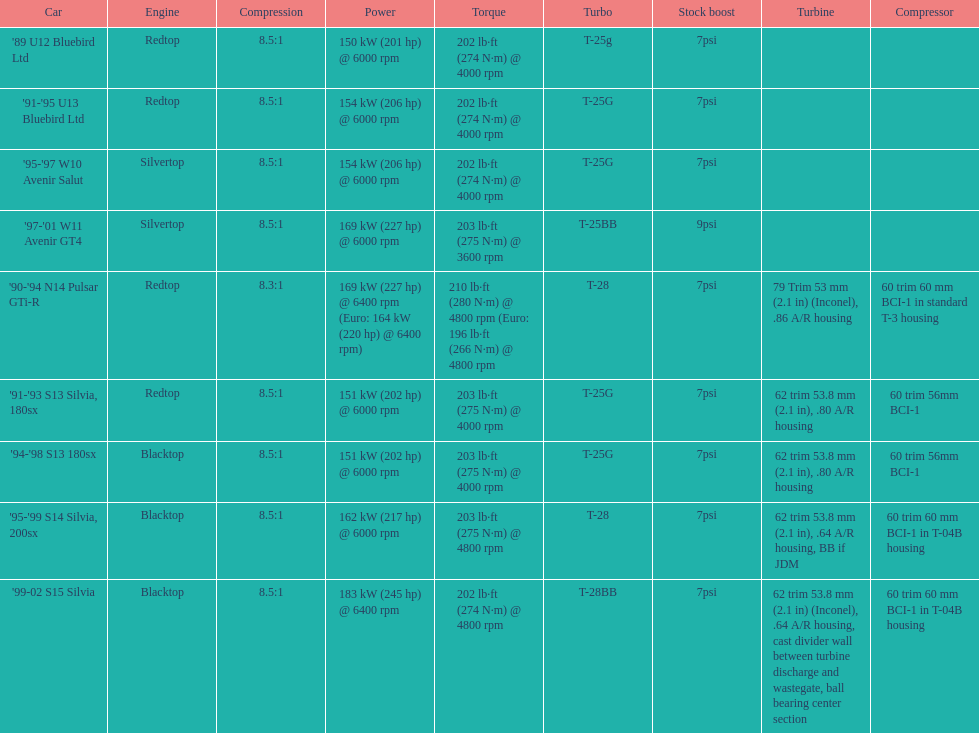In which engine can the smallest compression rate be found? '90-'94 N14 Pulsar GTi-R. Give me the full table as a dictionary. {'header': ['Car', 'Engine', 'Compression', 'Power', 'Torque', 'Turbo', 'Stock boost', 'Turbine', 'Compressor'], 'rows': [["'89 U12 Bluebird Ltd", 'Redtop', '8.5:1', '150\xa0kW (201\xa0hp) @ 6000 rpm', '202\xa0lb·ft (274\xa0N·m) @ 4000 rpm', 'T-25g', '7psi', '', ''], ["'91-'95 U13 Bluebird Ltd", 'Redtop', '8.5:1', '154\xa0kW (206\xa0hp) @ 6000 rpm', '202\xa0lb·ft (274\xa0N·m) @ 4000 rpm', 'T-25G', '7psi', '', ''], ["'95-'97 W10 Avenir Salut", 'Silvertop', '8.5:1', '154\xa0kW (206\xa0hp) @ 6000 rpm', '202\xa0lb·ft (274\xa0N·m) @ 4000 rpm', 'T-25G', '7psi', '', ''], ["'97-'01 W11 Avenir GT4", 'Silvertop', '8.5:1', '169\xa0kW (227\xa0hp) @ 6000 rpm', '203\xa0lb·ft (275\xa0N·m) @ 3600 rpm', 'T-25BB', '9psi', '', ''], ["'90-'94 N14 Pulsar GTi-R", 'Redtop', '8.3:1', '169\xa0kW (227\xa0hp) @ 6400 rpm (Euro: 164\xa0kW (220\xa0hp) @ 6400 rpm)', '210\xa0lb·ft (280\xa0N·m) @ 4800 rpm (Euro: 196\xa0lb·ft (266\xa0N·m) @ 4800 rpm', 'T-28', '7psi', '79 Trim 53\xa0mm (2.1\xa0in) (Inconel), .86 A/R housing', '60 trim 60\xa0mm BCI-1 in standard T-3 housing'], ["'91-'93 S13 Silvia, 180sx", 'Redtop', '8.5:1', '151\xa0kW (202\xa0hp) @ 6000 rpm', '203\xa0lb·ft (275\xa0N·m) @ 4000 rpm', 'T-25G', '7psi', '62 trim 53.8\xa0mm (2.1\xa0in), .80 A/R housing', '60 trim 56mm BCI-1'], ["'94-'98 S13 180sx", 'Blacktop', '8.5:1', '151\xa0kW (202\xa0hp) @ 6000 rpm', '203\xa0lb·ft (275\xa0N·m) @ 4000 rpm', 'T-25G', '7psi', '62 trim 53.8\xa0mm (2.1\xa0in), .80 A/R housing', '60 trim 56mm BCI-1'], ["'95-'99 S14 Silvia, 200sx", 'Blacktop', '8.5:1', '162\xa0kW (217\xa0hp) @ 6000 rpm', '203\xa0lb·ft (275\xa0N·m) @ 4800 rpm', 'T-28', '7psi', '62 trim 53.8\xa0mm (2.1\xa0in), .64 A/R housing, BB if JDM', '60 trim 60\xa0mm BCI-1 in T-04B housing'], ["'99-02 S15 Silvia", 'Blacktop', '8.5:1', '183\xa0kW (245\xa0hp) @ 6400 rpm', '202\xa0lb·ft (274\xa0N·m) @ 4800 rpm', 'T-28BB', '7psi', '62 trim 53.8\xa0mm (2.1\xa0in) (Inconel), .64 A/R housing, cast divider wall between turbine discharge and wastegate, ball bearing center section', '60 trim 60\xa0mm BCI-1 in T-04B housing']]} 